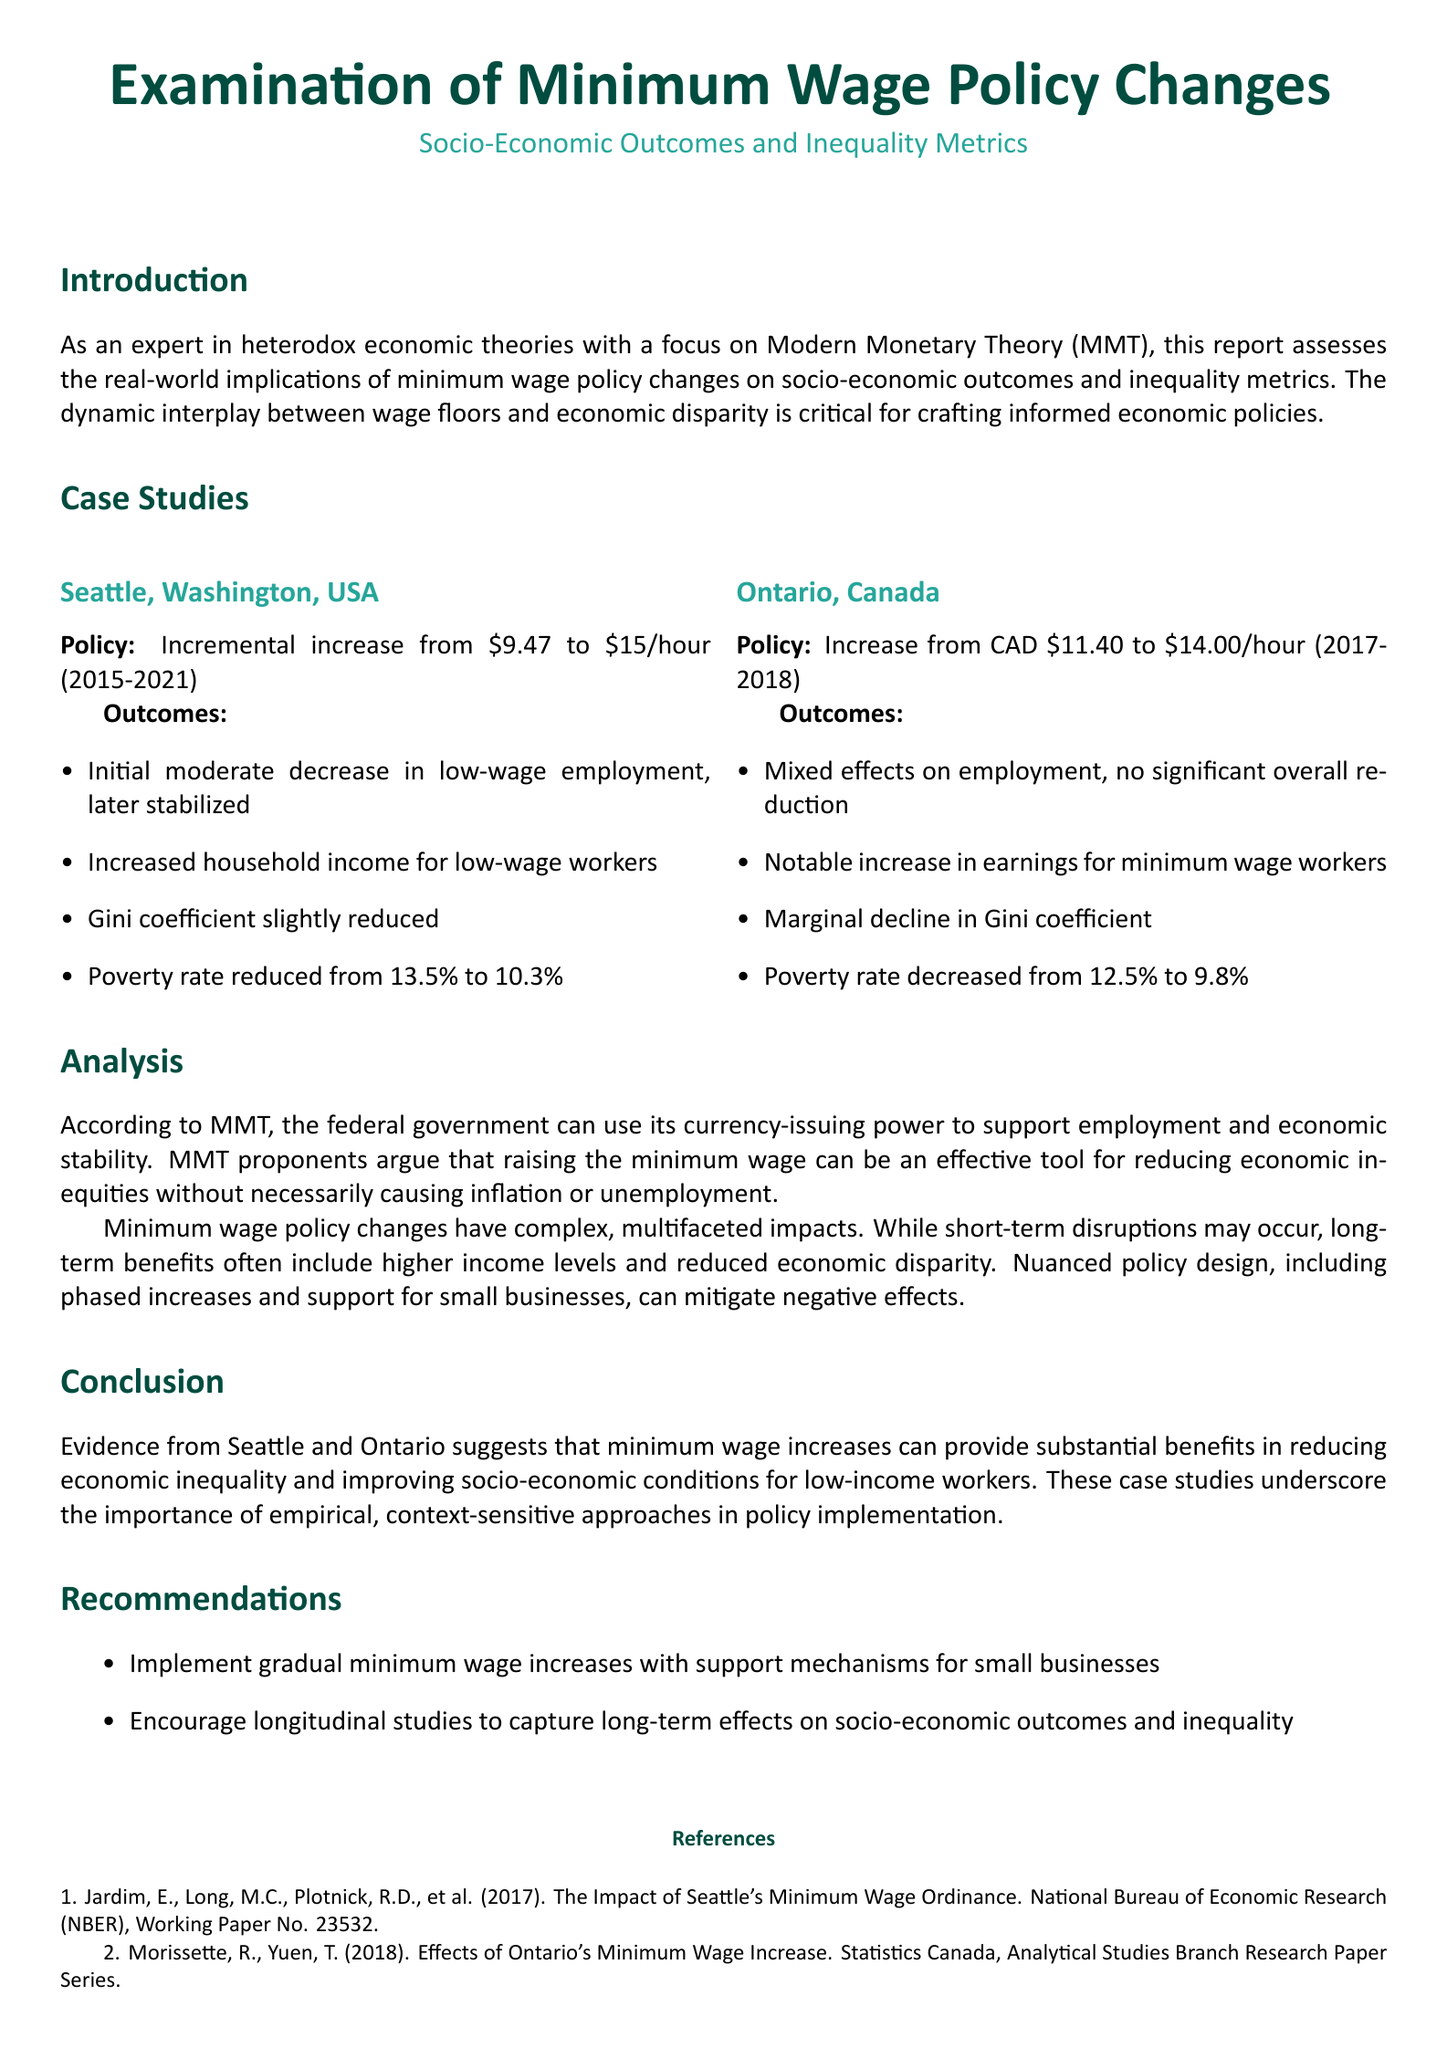What was the minimum wage increase in Seattle? The minimum wage increased from $9.47 to $15/hour between 2015 and 2021.
Answer: $9.47 to $15/hour What was the poverty rate reduction in Seattle? The poverty rate in Seattle decreased from 13.5% to 10.3% after the wage increase.
Answer: 3.2% What were the employment effects in Ontario after the wage increase? The wage increase in Ontario had mixed effects on employment with no significant overall reduction.
Answer: Mixed effects What is the Gini coefficient trend in Ontario after the policy change? The Gini coefficient in Ontario experienced a marginal decline following the wage increase.
Answer: Marginal decline What is one of the recommendations mentioned in the report? One recommendation is to implement gradual minimum wage increases with support mechanisms for small businesses.
Answer: Gradual increases What do MMT proponents argue about raising the minimum wage? MMT proponents argue that raising the minimum wage can effectively reduce economic inequities without necessarily causing inflation or unemployment.
Answer: Reduce economic inequities What is the poverty rate reduction in Ontario? The poverty rate in Ontario decreased from 12.5% to 9.8% as a result of the wage increase.
Answer: 2.7% What period did the Seattle policy changes cover? The Seattle minimum wage policy changes took place from 2015 to 2021.
Answer: 2015-2021 What type of studies do the recommendations encourage? The recommendations encourage longitudinal studies to capture long-term effects on socio-economic outcomes and inequality.
Answer: Longitudinal studies 